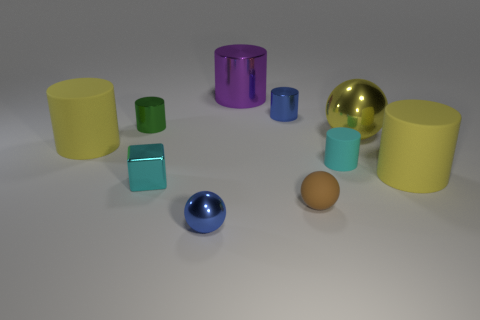What number of balls are brown objects or small metallic objects? In the image, there is one small metallic ball which is gold in color, and while there are no brown balls, there is a single brown egg-shaped object. Therefore, if considering only the ball, there is one small metallic ball, but if considering any small brown object, the answer would be two. 